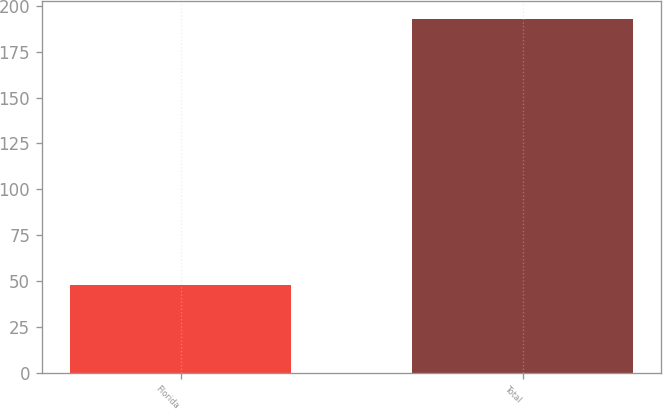<chart> <loc_0><loc_0><loc_500><loc_500><bar_chart><fcel>Florida<fcel>Total<nl><fcel>48<fcel>193<nl></chart> 